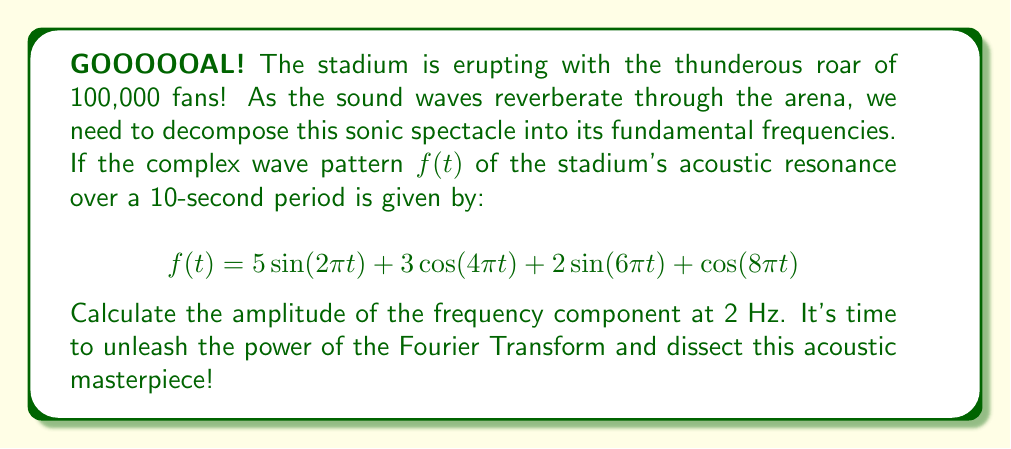Help me with this question. Alright, sports fans! Let's break down this sonic puzzle step by step:

1) First, we need to identify the frequencies in our complex wave. The general form of a sinusoidal component is $A\sin(2\pi ft)$ or $A\cos(2\pi ft)$, where $f$ is the frequency in Hz.

2) Looking at our function:
   $$f(t) = 5\sin(2\pi t) + 3\cos(4\pi t) + 2\sin(6\pi t) + \cos(8\pi t)$$

   We can identify the frequencies:
   - $5\sin(2\pi t)$: $f = 1$ Hz
   - $3\cos(4\pi t)$: $f = 2$ Hz
   - $2\sin(6\pi t)$: $f = 3$ Hz
   - $\cos(8\pi t)$: $f = 4$ Hz

3) We're asked about the 2 Hz component, which corresponds to $3\cos(4\pi t)$.

4) In the Fourier Transform, the amplitude of a cosine component is given directly by its coefficient. For a sine component, we'd need to consider both sine and cosine terms, but we don't have that complication here.

5) Therefore, the amplitude of the 2 Hz frequency component is simply 3.

And there you have it, folks! We've isolated the 2 Hz frequency from this sonic tsunami with the precision of a world-class striker finding the back of the net!
Answer: The amplitude of the 2 Hz frequency component is 3. 